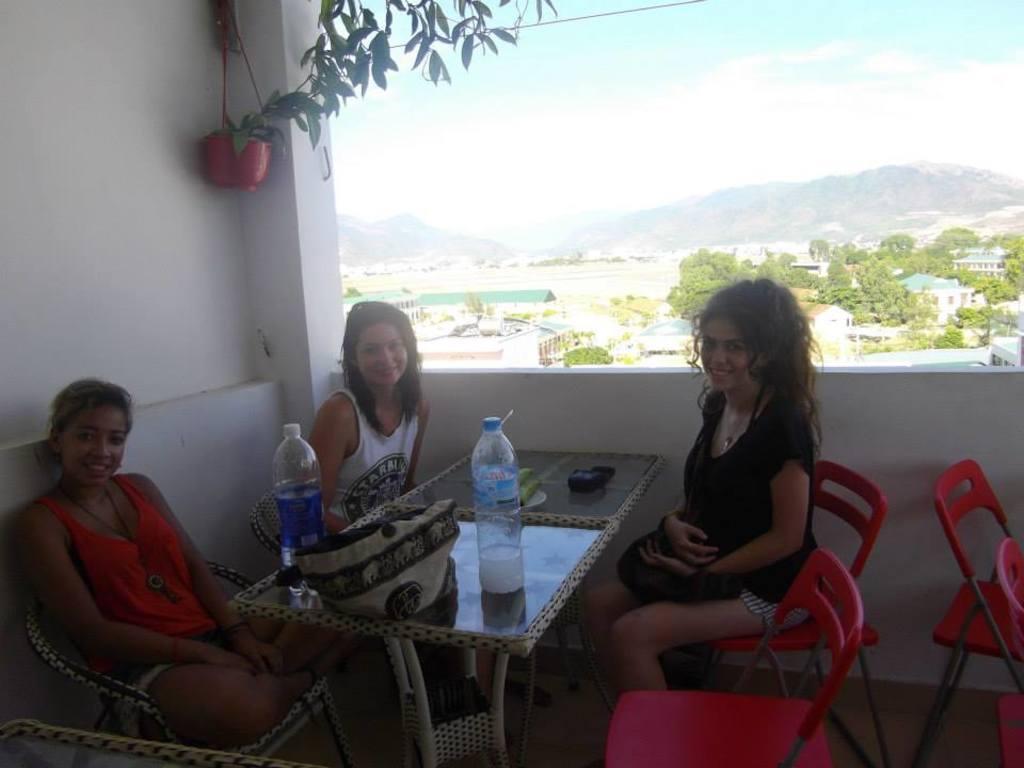Describe this image in one or two sentences. As we can see in the image, there is a plant, sky, hill, trees and three people sitting on chairs and there is a table. On table there is a handbag and bottles. 